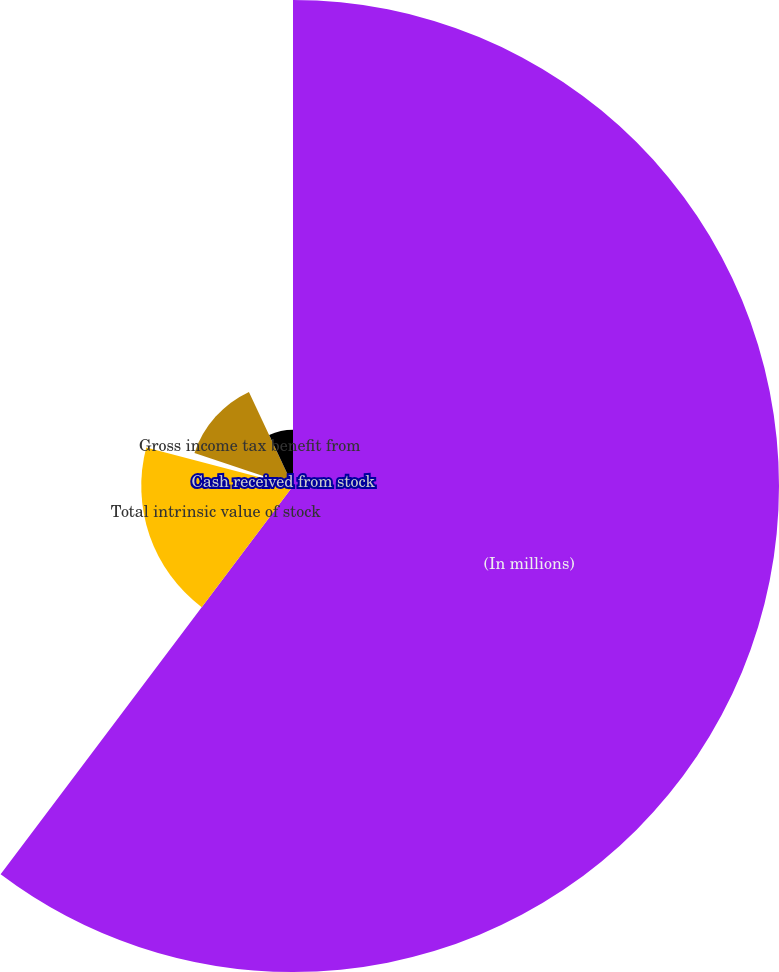Convert chart. <chart><loc_0><loc_0><loc_500><loc_500><pie_chart><fcel>(In millions)<fcel>Total intrinsic value of stock<fcel>Cash received from stock<fcel>Gross income tax benefit from<fcel>Fair value of restricted stock<nl><fcel>60.28%<fcel>18.82%<fcel>1.05%<fcel>12.89%<fcel>6.97%<nl></chart> 